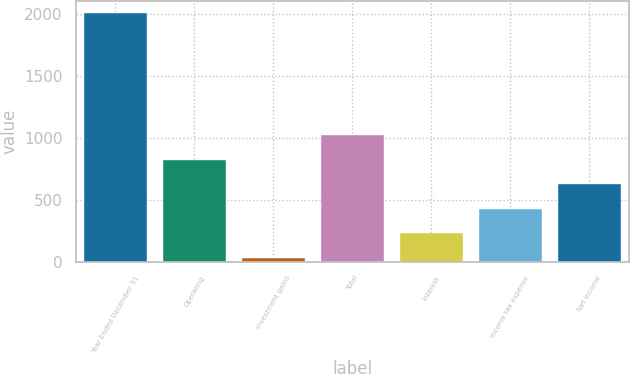Convert chart to OTSL. <chart><loc_0><loc_0><loc_500><loc_500><bar_chart><fcel>Year Ended December 31<fcel>Operating<fcel>Investment gains<fcel>Total<fcel>Interest<fcel>Income tax expense<fcel>Net income<nl><fcel>2007<fcel>822<fcel>32<fcel>1019.5<fcel>229.5<fcel>427<fcel>624.5<nl></chart> 